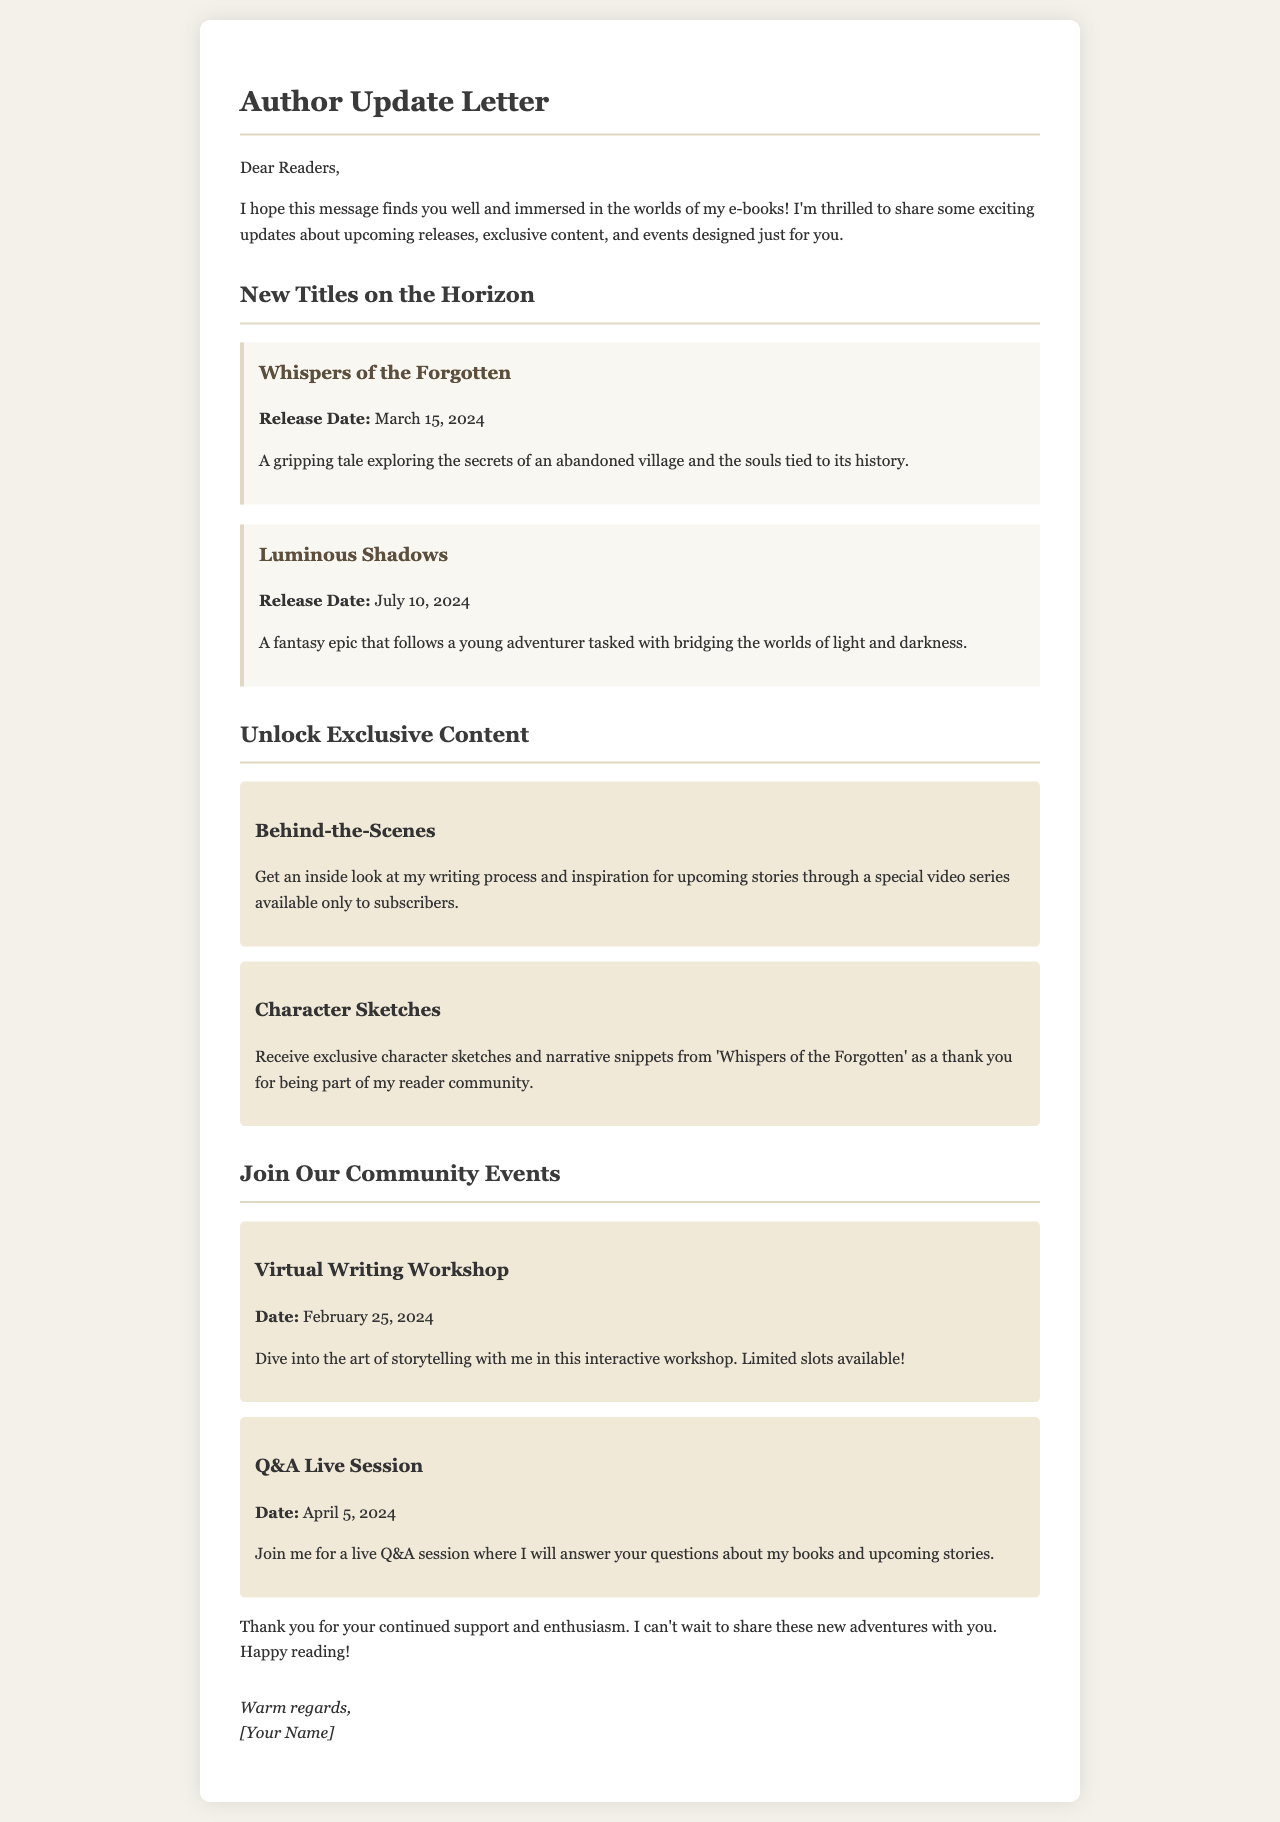what is the release date for "Whispers of the Forgotten"? The release date is specified in the document under the title "Whispers of the Forgotten."
Answer: March 15, 2024 what type of content is offered to subscribers? The document outlines exclusive content available to subscribers, which includes insights into the author's process.
Answer: Behind-the-Scenes what is the date for the Virtual Writing Workshop? The date for the workshop is mentioned in the events section of the document.
Answer: February 25, 2024 how many upcoming e-book titles are mentioned? The number of titles can be deduced by counting the entries under "New Titles on the Horizon."
Answer: Two which upcoming book involves a village's secrets? The document provides a brief description of a story related to an abandoned village.
Answer: Whispers of the Forgotten what activity is scheduled for April 5, 2024? The event scheduled for that date is indicated in the document as a live interaction with readers.
Answer: Q&A Live Session what kind of sketches are offered to the readers? The document mentions the type of sketches provided as a thank you to readers.
Answer: Character Sketches what emotions does the author express towards the readers? The author's feelings towards the readers can be inferred from the closing remarks in the letter.
Answer: Warm regards 